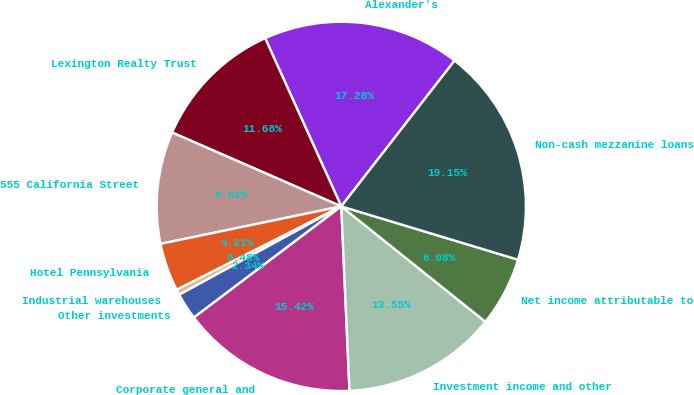<chart> <loc_0><loc_0><loc_500><loc_500><pie_chart><fcel>Alexander's<fcel>Lexington Realty Trust<fcel>555 California Street<fcel>Hotel Pennsylvania<fcel>Industrial warehouses<fcel>Other investments<fcel>Corporate general and<fcel>Investment income and other<fcel>Net income attributable to<fcel>Non-cash mezzanine loans<nl><fcel>17.28%<fcel>11.68%<fcel>9.81%<fcel>4.21%<fcel>0.48%<fcel>2.34%<fcel>15.42%<fcel>13.55%<fcel>6.08%<fcel>19.15%<nl></chart> 